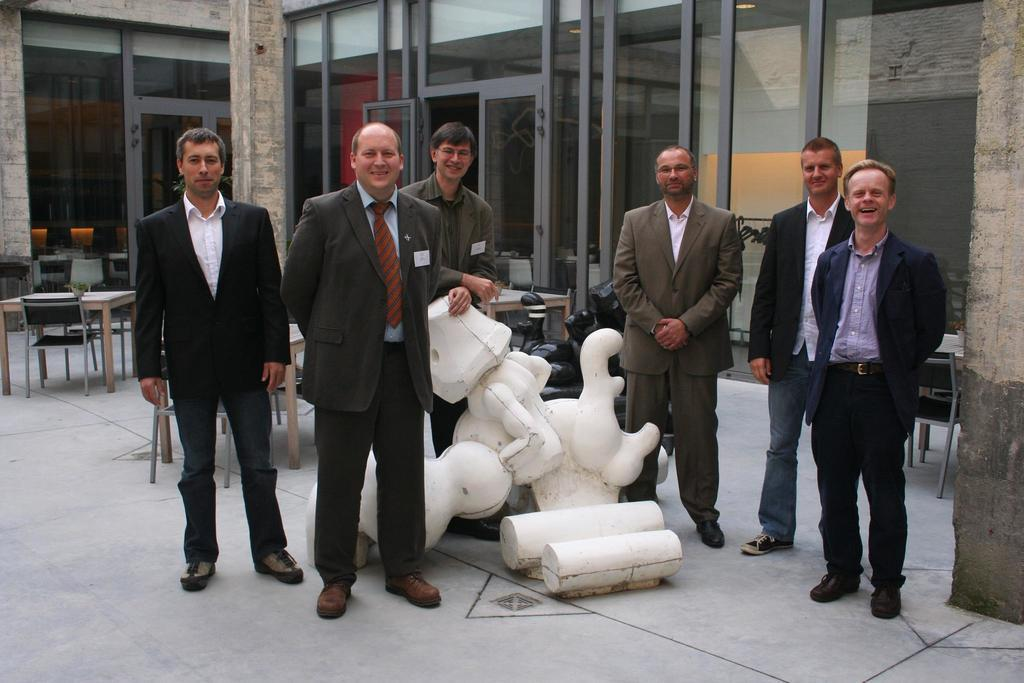How many people are in the image? There is a group of people in the image, but the exact number is not specified. What is in front of the group of people? There is a sculpture in front of the group of people. What type of furniture is visible behind the group of people? There are chairs and tables behind the group of people. What can be seen through the glass wall behind the group of people? There is a wide glass wall behind the group of people, but the view through it is not described. What type of trail can be seen leading up to the group of people in the image? There is no trail visible in the image; it only shows a group of people, a sculpture, chairs, tables, and a glass wall. 